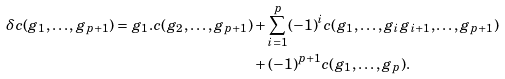<formula> <loc_0><loc_0><loc_500><loc_500>\delta c ( g _ { 1 } , \dots , g _ { p + 1 } ) = g _ { 1 } . c ( g _ { 2 } , \dots , g _ { p + 1 } ) & + \sum _ { i = 1 } ^ { p } ( - 1 ) ^ { i } c ( g _ { 1 } , \dots , g _ { i } g _ { i + 1 } , \dots , g _ { p + 1 } ) \\ & + ( - 1 ) ^ { p + 1 } c ( g _ { 1 } , \dots , g _ { p } ) .</formula> 